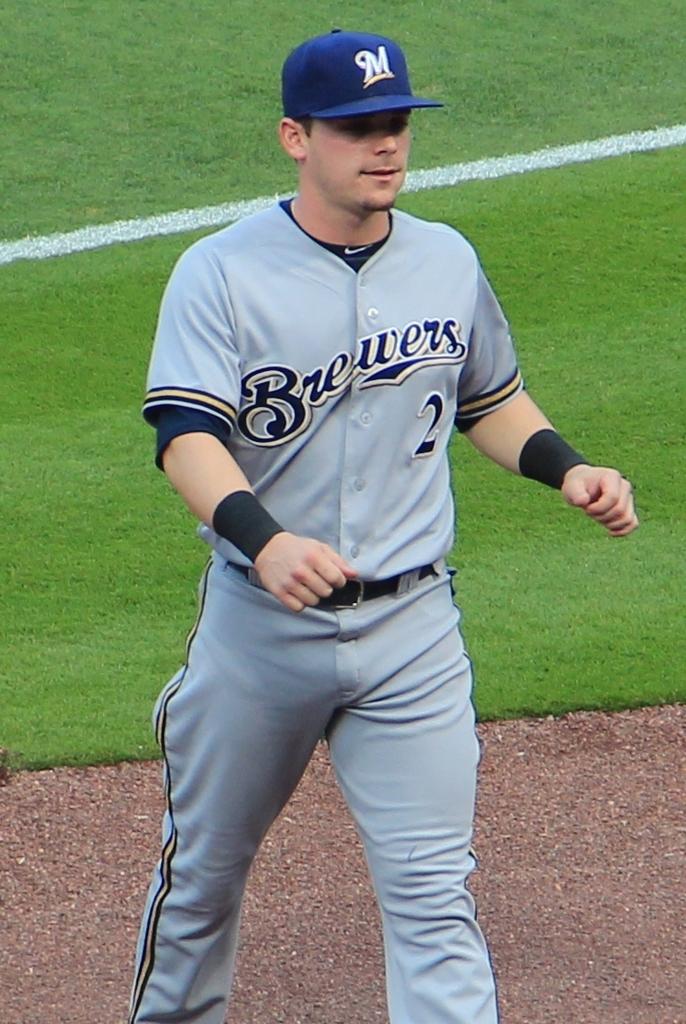What team is this player on?
Make the answer very short. Brewers. 